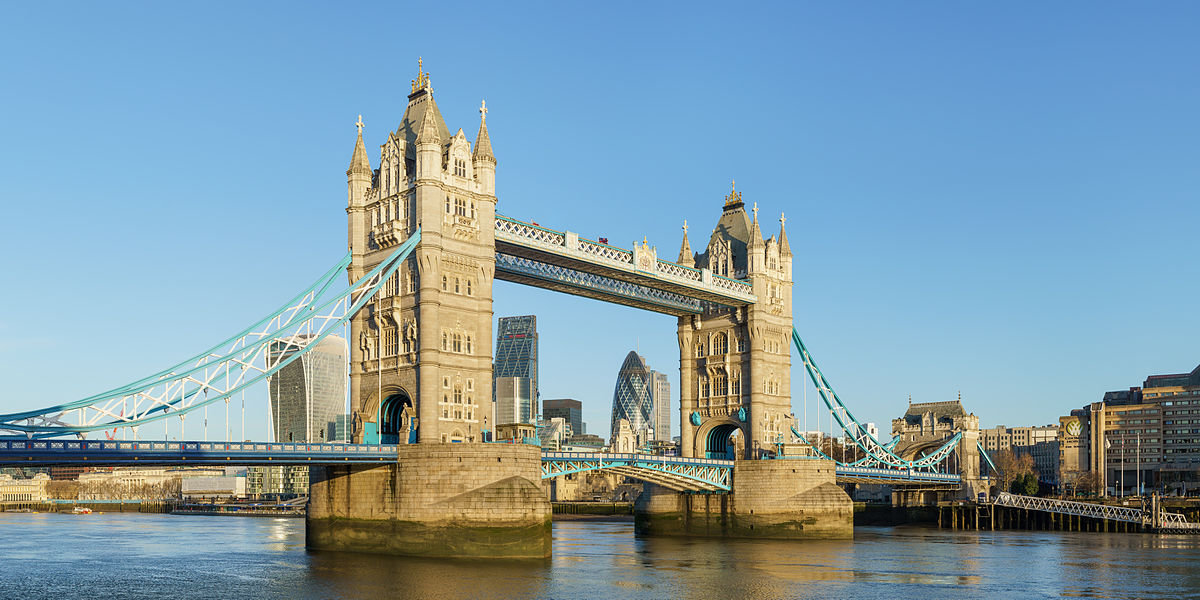Can you tell more about the history of Tower Bridge? Tower Bridge, completed in 1894, is a combined bascule and suspension bridge in London, built to ease traffic while maintaining river access to the busy Pool of London docks. Designed by Sir Horace Jones and his engineer, Sir John Wolfe Barry, it features two towers tied together at the upper level by two horizontal walkways, designed to withstand the forces imparted by the suspended sections of the bridge. 